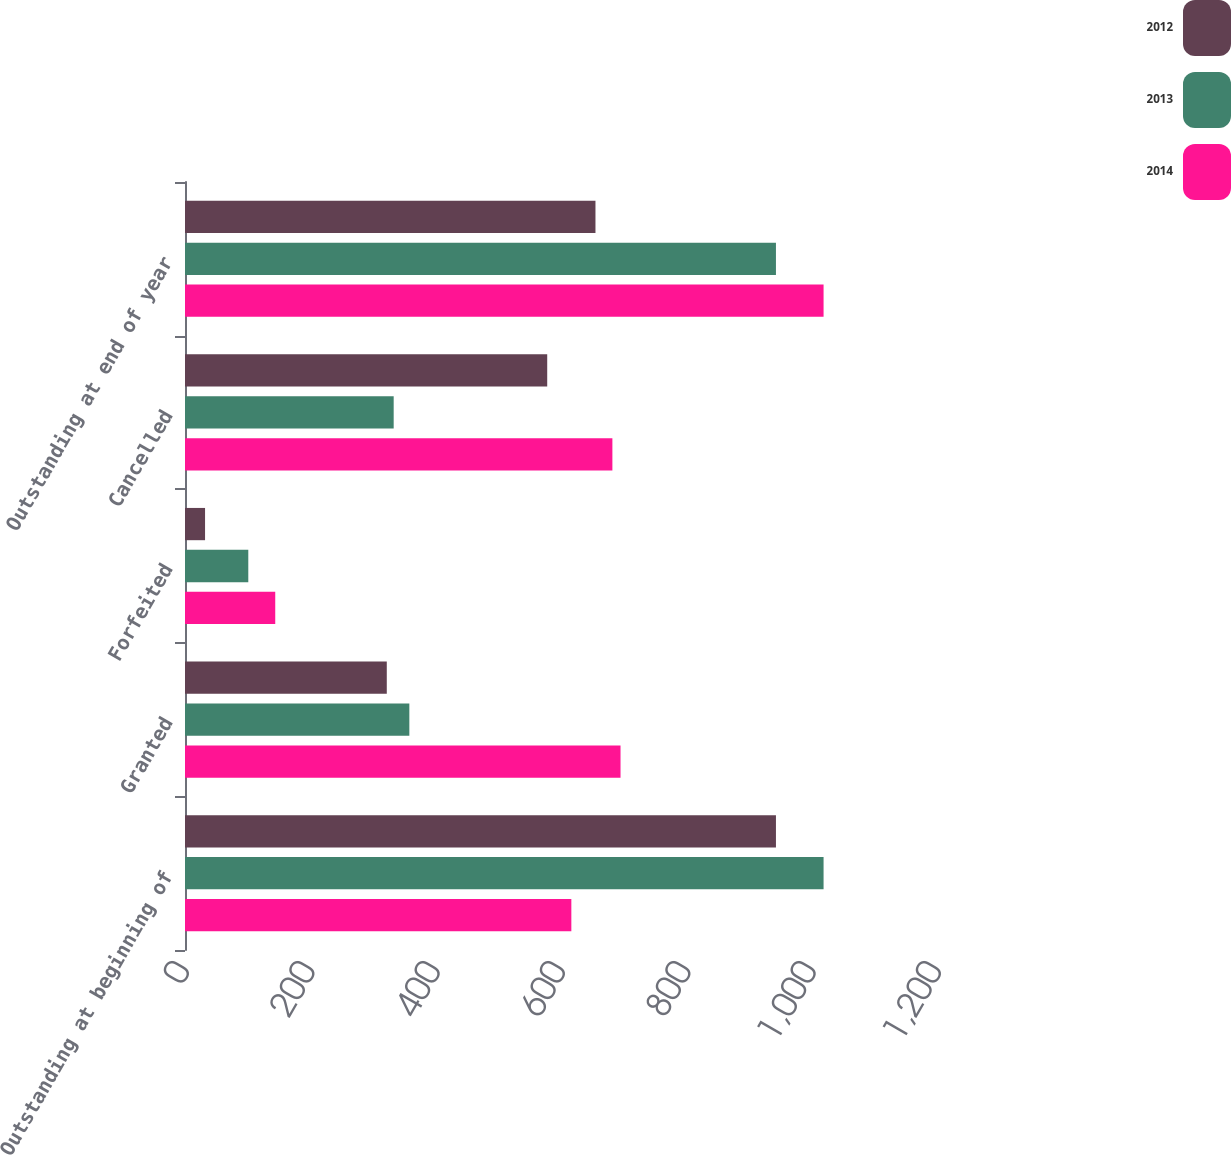<chart> <loc_0><loc_0><loc_500><loc_500><stacked_bar_chart><ecel><fcel>Outstanding at beginning of<fcel>Granted<fcel>Forfeited<fcel>Cancelled<fcel>Outstanding at end of year<nl><fcel>2012<fcel>943<fcel>322<fcel>32<fcel>578<fcel>655<nl><fcel>2013<fcel>1019<fcel>358<fcel>101<fcel>333<fcel>943<nl><fcel>2014<fcel>616.5<fcel>695<fcel>144<fcel>682<fcel>1019<nl></chart> 